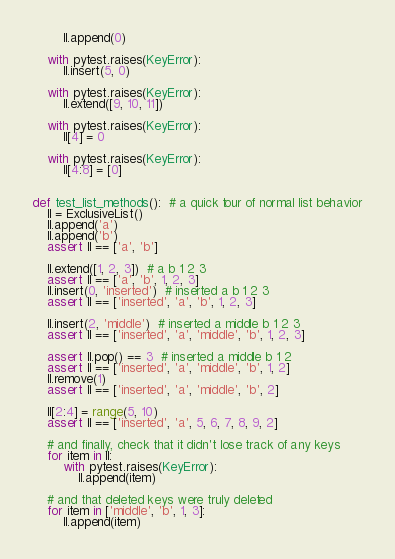<code> <loc_0><loc_0><loc_500><loc_500><_Python_>        ll.append(0)

    with pytest.raises(KeyError):
        ll.insert(5, 0)

    with pytest.raises(KeyError):
        ll.extend([9, 10, 11])

    with pytest.raises(KeyError):
        ll[4] = 0

    with pytest.raises(KeyError):
        ll[4:8] = [0]


def test_list_methods():  # a quick tour of normal list behavior
    ll = ExclusiveList()
    ll.append('a')
    ll.append('b')
    assert ll == ['a', 'b']

    ll.extend([1, 2, 3])  # a b 1 2 3
    assert ll == ['a', 'b', 1, 2, 3]
    ll.insert(0, 'inserted')  # inserted a b 1 2 3
    assert ll == ['inserted', 'a', 'b', 1, 2, 3]

    ll.insert(2, 'middle')  # inserted a middle b 1 2 3
    assert ll == ['inserted', 'a', 'middle', 'b', 1, 2, 3]

    assert ll.pop() == 3  # inserted a middle b 1 2
    assert ll == ['inserted', 'a', 'middle', 'b', 1, 2]
    ll.remove(1)
    assert ll == ['inserted', 'a', 'middle', 'b', 2]

    ll[2:4] = range(5, 10)
    assert ll == ['inserted', 'a', 5, 6, 7, 8, 9, 2]

    # and finally, check that it didn't lose track of any keys
    for item in ll:
        with pytest.raises(KeyError):
            ll.append(item)

    # and that deleted keys were truly deleted
    for item in ['middle', 'b', 1, 3]:
        ll.append(item)
</code> 